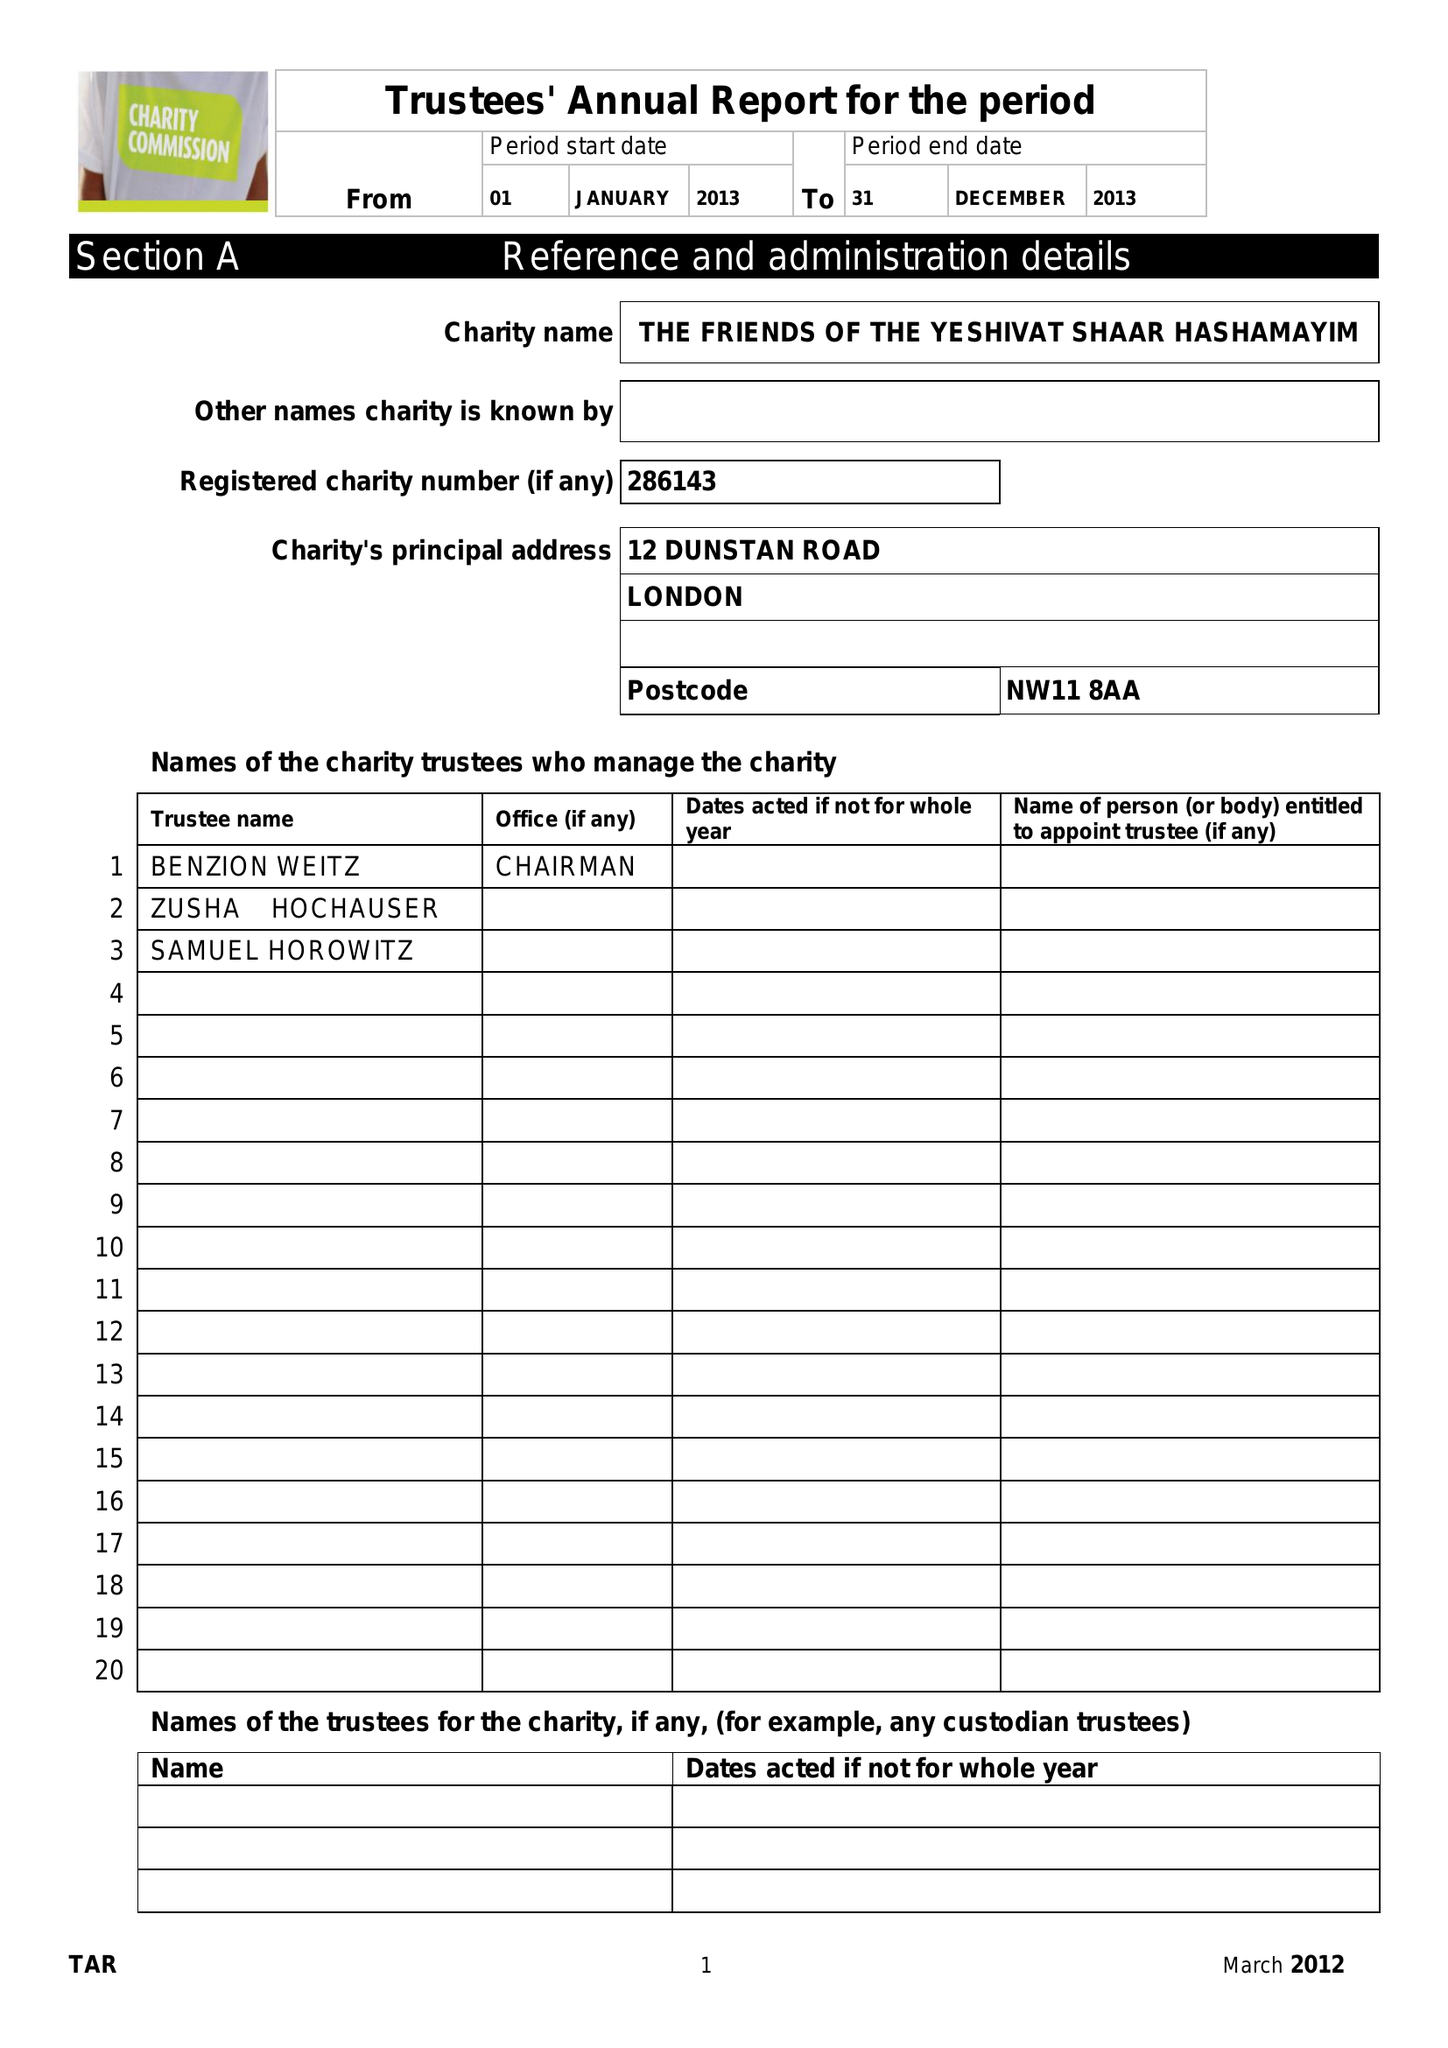What is the value for the address__post_town?
Answer the question using a single word or phrase. LONDON 